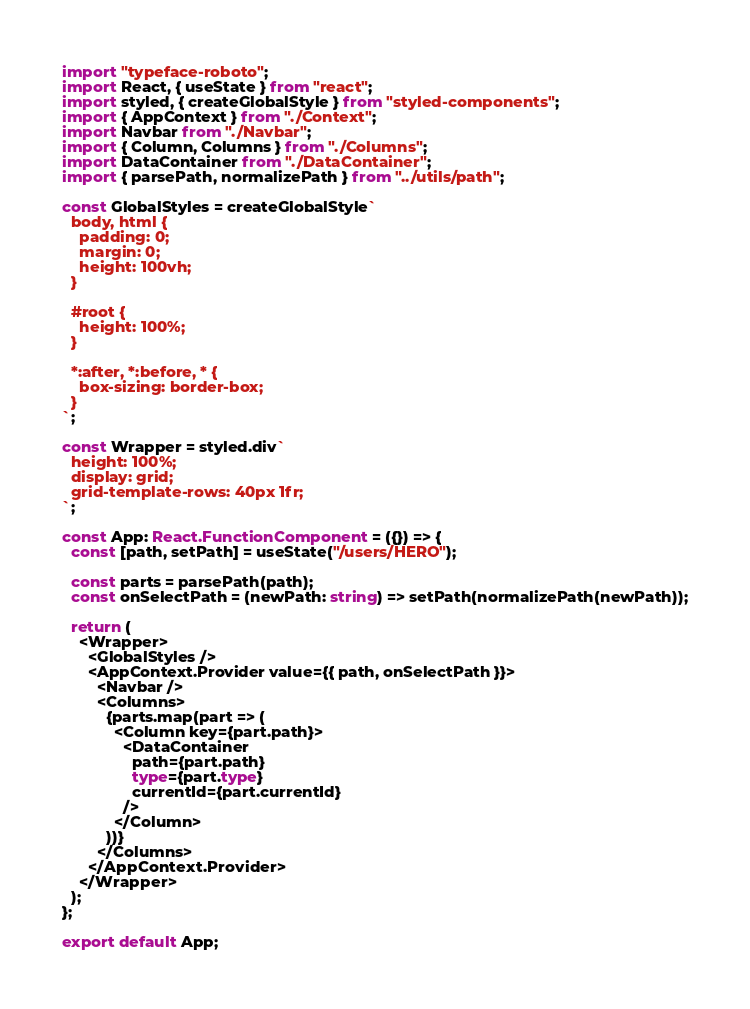<code> <loc_0><loc_0><loc_500><loc_500><_TypeScript_>import "typeface-roboto";
import React, { useState } from "react";
import styled, { createGlobalStyle } from "styled-components";
import { AppContext } from "./Context";
import Navbar from "./Navbar";
import { Column, Columns } from "./Columns";
import DataContainer from "./DataContainer";
import { parsePath, normalizePath } from "../utils/path";

const GlobalStyles = createGlobalStyle`
  body, html {
    padding: 0;
    margin: 0;
    height: 100vh;
  }

  #root {
    height: 100%;
  }

  *:after, *:before, * {
    box-sizing: border-box;
  }
`;

const Wrapper = styled.div`
  height: 100%;
  display: grid;
  grid-template-rows: 40px 1fr;
`;

const App: React.FunctionComponent = ({}) => {
  const [path, setPath] = useState("/users/HERO");

  const parts = parsePath(path);
  const onSelectPath = (newPath: string) => setPath(normalizePath(newPath));

  return (
    <Wrapper>
      <GlobalStyles />
      <AppContext.Provider value={{ path, onSelectPath }}>
        <Navbar />
        <Columns>
          {parts.map(part => (
            <Column key={part.path}>
              <DataContainer
                path={part.path}
                type={part.type}
                currentId={part.currentId}
              />
            </Column>
          ))}
        </Columns>
      </AppContext.Provider>
    </Wrapper>
  );
};

export default App;
</code> 